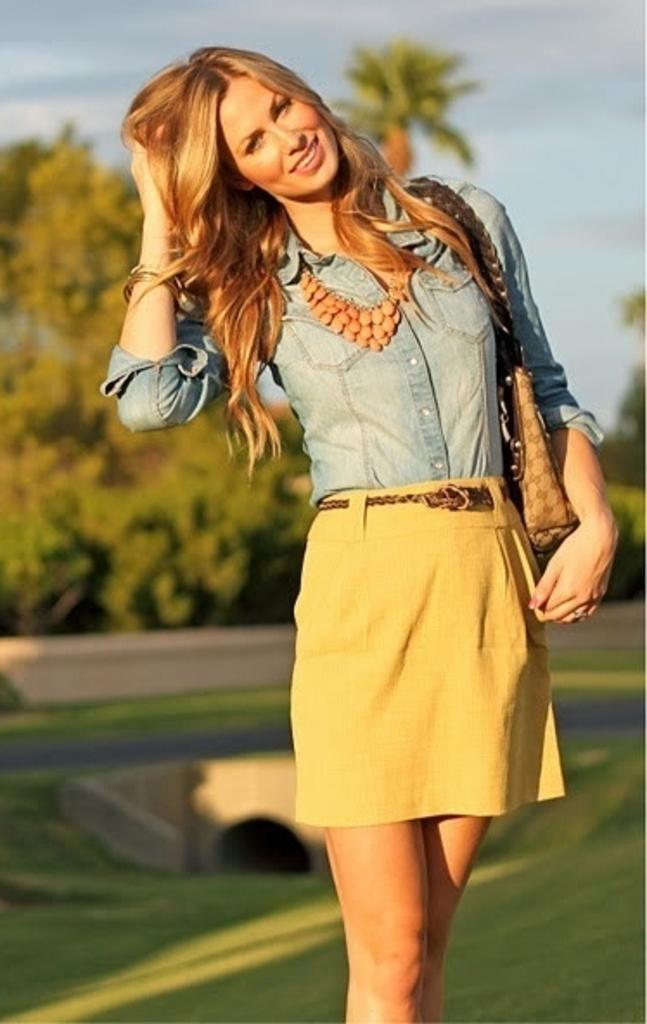What is the main subject of the image? There is a woman standing in the image. What type of natural environment is visible in the image? There is grass and trees visible in the image. What is visible in the background of the image? The sky is visible in the image. How would you describe the sky in the image? The sky appears to be cloudy in the image. Can you see any water or a bear in the image? No, there is no water or bear present in the image. Is there a marble statue visible in the image? No, there is no marble statue present in the image. 